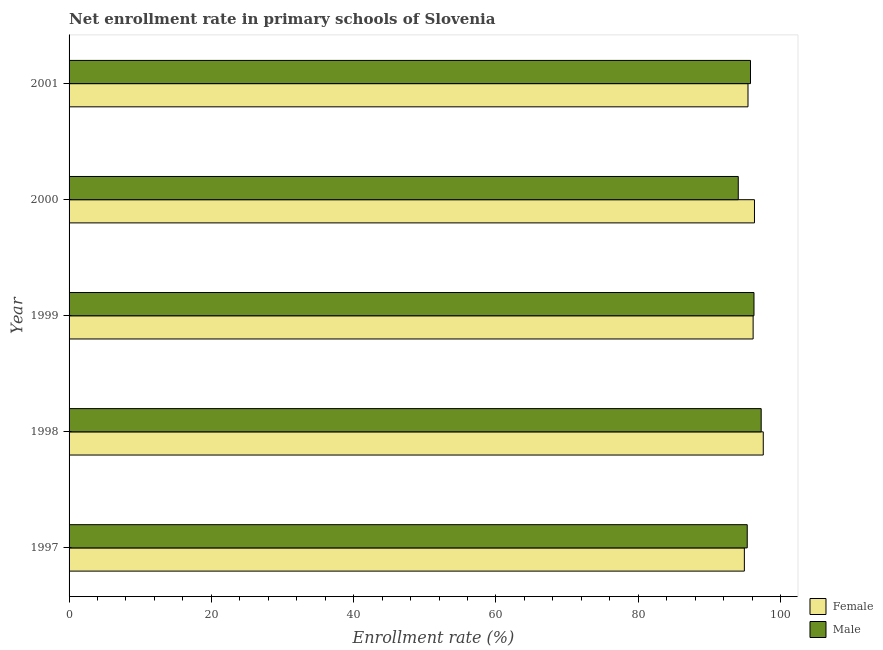How many different coloured bars are there?
Ensure brevity in your answer.  2. Are the number of bars per tick equal to the number of legend labels?
Offer a very short reply. Yes. Are the number of bars on each tick of the Y-axis equal?
Offer a very short reply. Yes. How many bars are there on the 5th tick from the top?
Your answer should be compact. 2. In how many cases, is the number of bars for a given year not equal to the number of legend labels?
Your answer should be very brief. 0. What is the enrollment rate of female students in 1998?
Keep it short and to the point. 97.57. Across all years, what is the maximum enrollment rate of male students?
Your answer should be very brief. 97.28. Across all years, what is the minimum enrollment rate of female students?
Your answer should be compact. 94.91. What is the total enrollment rate of female students in the graph?
Provide a succinct answer. 480.38. What is the difference between the enrollment rate of female students in 1997 and that in 1998?
Your response must be concise. -2.66. What is the difference between the enrollment rate of female students in 1998 and the enrollment rate of male students in 1997?
Provide a succinct answer. 2.25. What is the average enrollment rate of male students per year?
Provide a succinct answer. 95.74. In the year 1999, what is the difference between the enrollment rate of male students and enrollment rate of female students?
Ensure brevity in your answer.  0.12. In how many years, is the enrollment rate of female students greater than 12 %?
Offer a terse response. 5. What is the ratio of the enrollment rate of male students in 1997 to that in 1998?
Your answer should be compact. 0.98. Is the enrollment rate of female students in 1998 less than that in 2001?
Make the answer very short. No. Is the difference between the enrollment rate of male students in 1997 and 2000 greater than the difference between the enrollment rate of female students in 1997 and 2000?
Your response must be concise. Yes. What is the difference between the highest and the lowest enrollment rate of female students?
Your response must be concise. 2.66. In how many years, is the enrollment rate of male students greater than the average enrollment rate of male students taken over all years?
Make the answer very short. 3. Is the sum of the enrollment rate of male students in 1998 and 1999 greater than the maximum enrollment rate of female students across all years?
Offer a terse response. Yes. What does the 1st bar from the top in 1998 represents?
Your response must be concise. Male. What does the 1st bar from the bottom in 2001 represents?
Your response must be concise. Female. How many bars are there?
Make the answer very short. 10. What is the difference between two consecutive major ticks on the X-axis?
Make the answer very short. 20. Does the graph contain any zero values?
Provide a short and direct response. No. Where does the legend appear in the graph?
Your response must be concise. Bottom right. How are the legend labels stacked?
Offer a terse response. Vertical. What is the title of the graph?
Your answer should be very brief. Net enrollment rate in primary schools of Slovenia. Does "Forest" appear as one of the legend labels in the graph?
Keep it short and to the point. No. What is the label or title of the X-axis?
Make the answer very short. Enrollment rate (%). What is the Enrollment rate (%) in Female in 1997?
Keep it short and to the point. 94.91. What is the Enrollment rate (%) in Male in 1997?
Your answer should be compact. 95.32. What is the Enrollment rate (%) in Female in 1998?
Give a very brief answer. 97.57. What is the Enrollment rate (%) in Male in 1998?
Offer a terse response. 97.28. What is the Enrollment rate (%) of Female in 1999?
Your answer should be very brief. 96.14. What is the Enrollment rate (%) in Male in 1999?
Offer a very short reply. 96.26. What is the Enrollment rate (%) in Female in 2000?
Provide a succinct answer. 96.33. What is the Enrollment rate (%) of Male in 2000?
Your answer should be compact. 94.06. What is the Enrollment rate (%) in Female in 2001?
Provide a succinct answer. 95.42. What is the Enrollment rate (%) in Male in 2001?
Your answer should be compact. 95.77. Across all years, what is the maximum Enrollment rate (%) of Female?
Give a very brief answer. 97.57. Across all years, what is the maximum Enrollment rate (%) of Male?
Your answer should be very brief. 97.28. Across all years, what is the minimum Enrollment rate (%) in Female?
Give a very brief answer. 94.91. Across all years, what is the minimum Enrollment rate (%) of Male?
Your response must be concise. 94.06. What is the total Enrollment rate (%) of Female in the graph?
Your answer should be compact. 480.38. What is the total Enrollment rate (%) in Male in the graph?
Offer a terse response. 478.69. What is the difference between the Enrollment rate (%) of Female in 1997 and that in 1998?
Your answer should be compact. -2.66. What is the difference between the Enrollment rate (%) in Male in 1997 and that in 1998?
Your answer should be compact. -1.96. What is the difference between the Enrollment rate (%) of Female in 1997 and that in 1999?
Give a very brief answer. -1.23. What is the difference between the Enrollment rate (%) in Male in 1997 and that in 1999?
Your answer should be compact. -0.95. What is the difference between the Enrollment rate (%) of Female in 1997 and that in 2000?
Your answer should be very brief. -1.42. What is the difference between the Enrollment rate (%) of Male in 1997 and that in 2000?
Provide a short and direct response. 1.26. What is the difference between the Enrollment rate (%) of Female in 1997 and that in 2001?
Offer a terse response. -0.51. What is the difference between the Enrollment rate (%) of Male in 1997 and that in 2001?
Your answer should be compact. -0.46. What is the difference between the Enrollment rate (%) of Female in 1998 and that in 1999?
Offer a terse response. 1.43. What is the difference between the Enrollment rate (%) in Male in 1998 and that in 1999?
Provide a short and direct response. 1.01. What is the difference between the Enrollment rate (%) in Female in 1998 and that in 2000?
Your answer should be compact. 1.24. What is the difference between the Enrollment rate (%) in Male in 1998 and that in 2000?
Your answer should be very brief. 3.22. What is the difference between the Enrollment rate (%) in Female in 1998 and that in 2001?
Keep it short and to the point. 2.15. What is the difference between the Enrollment rate (%) in Male in 1998 and that in 2001?
Your answer should be very brief. 1.5. What is the difference between the Enrollment rate (%) in Female in 1999 and that in 2000?
Keep it short and to the point. -0.19. What is the difference between the Enrollment rate (%) of Male in 1999 and that in 2000?
Keep it short and to the point. 2.21. What is the difference between the Enrollment rate (%) in Female in 1999 and that in 2001?
Make the answer very short. 0.72. What is the difference between the Enrollment rate (%) in Male in 1999 and that in 2001?
Ensure brevity in your answer.  0.49. What is the difference between the Enrollment rate (%) of Female in 2000 and that in 2001?
Provide a succinct answer. 0.91. What is the difference between the Enrollment rate (%) of Male in 2000 and that in 2001?
Provide a short and direct response. -1.72. What is the difference between the Enrollment rate (%) of Female in 1997 and the Enrollment rate (%) of Male in 1998?
Make the answer very short. -2.36. What is the difference between the Enrollment rate (%) of Female in 1997 and the Enrollment rate (%) of Male in 1999?
Your answer should be very brief. -1.35. What is the difference between the Enrollment rate (%) of Female in 1997 and the Enrollment rate (%) of Male in 2000?
Offer a very short reply. 0.86. What is the difference between the Enrollment rate (%) of Female in 1997 and the Enrollment rate (%) of Male in 2001?
Keep it short and to the point. -0.86. What is the difference between the Enrollment rate (%) of Female in 1998 and the Enrollment rate (%) of Male in 1999?
Your answer should be very brief. 1.31. What is the difference between the Enrollment rate (%) in Female in 1998 and the Enrollment rate (%) in Male in 2000?
Make the answer very short. 3.51. What is the difference between the Enrollment rate (%) in Female in 1998 and the Enrollment rate (%) in Male in 2001?
Your response must be concise. 1.8. What is the difference between the Enrollment rate (%) in Female in 1999 and the Enrollment rate (%) in Male in 2000?
Keep it short and to the point. 2.09. What is the difference between the Enrollment rate (%) of Female in 1999 and the Enrollment rate (%) of Male in 2001?
Ensure brevity in your answer.  0.37. What is the difference between the Enrollment rate (%) in Female in 2000 and the Enrollment rate (%) in Male in 2001?
Your response must be concise. 0.56. What is the average Enrollment rate (%) of Female per year?
Make the answer very short. 96.08. What is the average Enrollment rate (%) in Male per year?
Keep it short and to the point. 95.74. In the year 1997, what is the difference between the Enrollment rate (%) in Female and Enrollment rate (%) in Male?
Make the answer very short. -0.41. In the year 1998, what is the difference between the Enrollment rate (%) in Female and Enrollment rate (%) in Male?
Offer a terse response. 0.29. In the year 1999, what is the difference between the Enrollment rate (%) of Female and Enrollment rate (%) of Male?
Offer a terse response. -0.12. In the year 2000, what is the difference between the Enrollment rate (%) of Female and Enrollment rate (%) of Male?
Provide a short and direct response. 2.28. In the year 2001, what is the difference between the Enrollment rate (%) of Female and Enrollment rate (%) of Male?
Offer a terse response. -0.35. What is the ratio of the Enrollment rate (%) in Female in 1997 to that in 1998?
Provide a succinct answer. 0.97. What is the ratio of the Enrollment rate (%) in Male in 1997 to that in 1998?
Provide a short and direct response. 0.98. What is the ratio of the Enrollment rate (%) in Female in 1997 to that in 1999?
Provide a succinct answer. 0.99. What is the ratio of the Enrollment rate (%) of Male in 1997 to that in 1999?
Provide a succinct answer. 0.99. What is the ratio of the Enrollment rate (%) in Female in 1997 to that in 2000?
Give a very brief answer. 0.99. What is the ratio of the Enrollment rate (%) of Male in 1997 to that in 2000?
Your response must be concise. 1.01. What is the ratio of the Enrollment rate (%) of Male in 1997 to that in 2001?
Keep it short and to the point. 1. What is the ratio of the Enrollment rate (%) of Female in 1998 to that in 1999?
Make the answer very short. 1.01. What is the ratio of the Enrollment rate (%) in Male in 1998 to that in 1999?
Provide a short and direct response. 1.01. What is the ratio of the Enrollment rate (%) in Female in 1998 to that in 2000?
Your answer should be compact. 1.01. What is the ratio of the Enrollment rate (%) in Male in 1998 to that in 2000?
Offer a terse response. 1.03. What is the ratio of the Enrollment rate (%) in Female in 1998 to that in 2001?
Your answer should be compact. 1.02. What is the ratio of the Enrollment rate (%) of Male in 1998 to that in 2001?
Make the answer very short. 1.02. What is the ratio of the Enrollment rate (%) in Female in 1999 to that in 2000?
Give a very brief answer. 1. What is the ratio of the Enrollment rate (%) in Male in 1999 to that in 2000?
Ensure brevity in your answer.  1.02. What is the ratio of the Enrollment rate (%) in Female in 1999 to that in 2001?
Offer a very short reply. 1.01. What is the ratio of the Enrollment rate (%) of Male in 1999 to that in 2001?
Your answer should be very brief. 1.01. What is the ratio of the Enrollment rate (%) of Female in 2000 to that in 2001?
Ensure brevity in your answer.  1.01. What is the ratio of the Enrollment rate (%) of Male in 2000 to that in 2001?
Provide a succinct answer. 0.98. What is the difference between the highest and the second highest Enrollment rate (%) in Female?
Make the answer very short. 1.24. What is the difference between the highest and the second highest Enrollment rate (%) of Male?
Ensure brevity in your answer.  1.01. What is the difference between the highest and the lowest Enrollment rate (%) of Female?
Give a very brief answer. 2.66. What is the difference between the highest and the lowest Enrollment rate (%) in Male?
Provide a short and direct response. 3.22. 